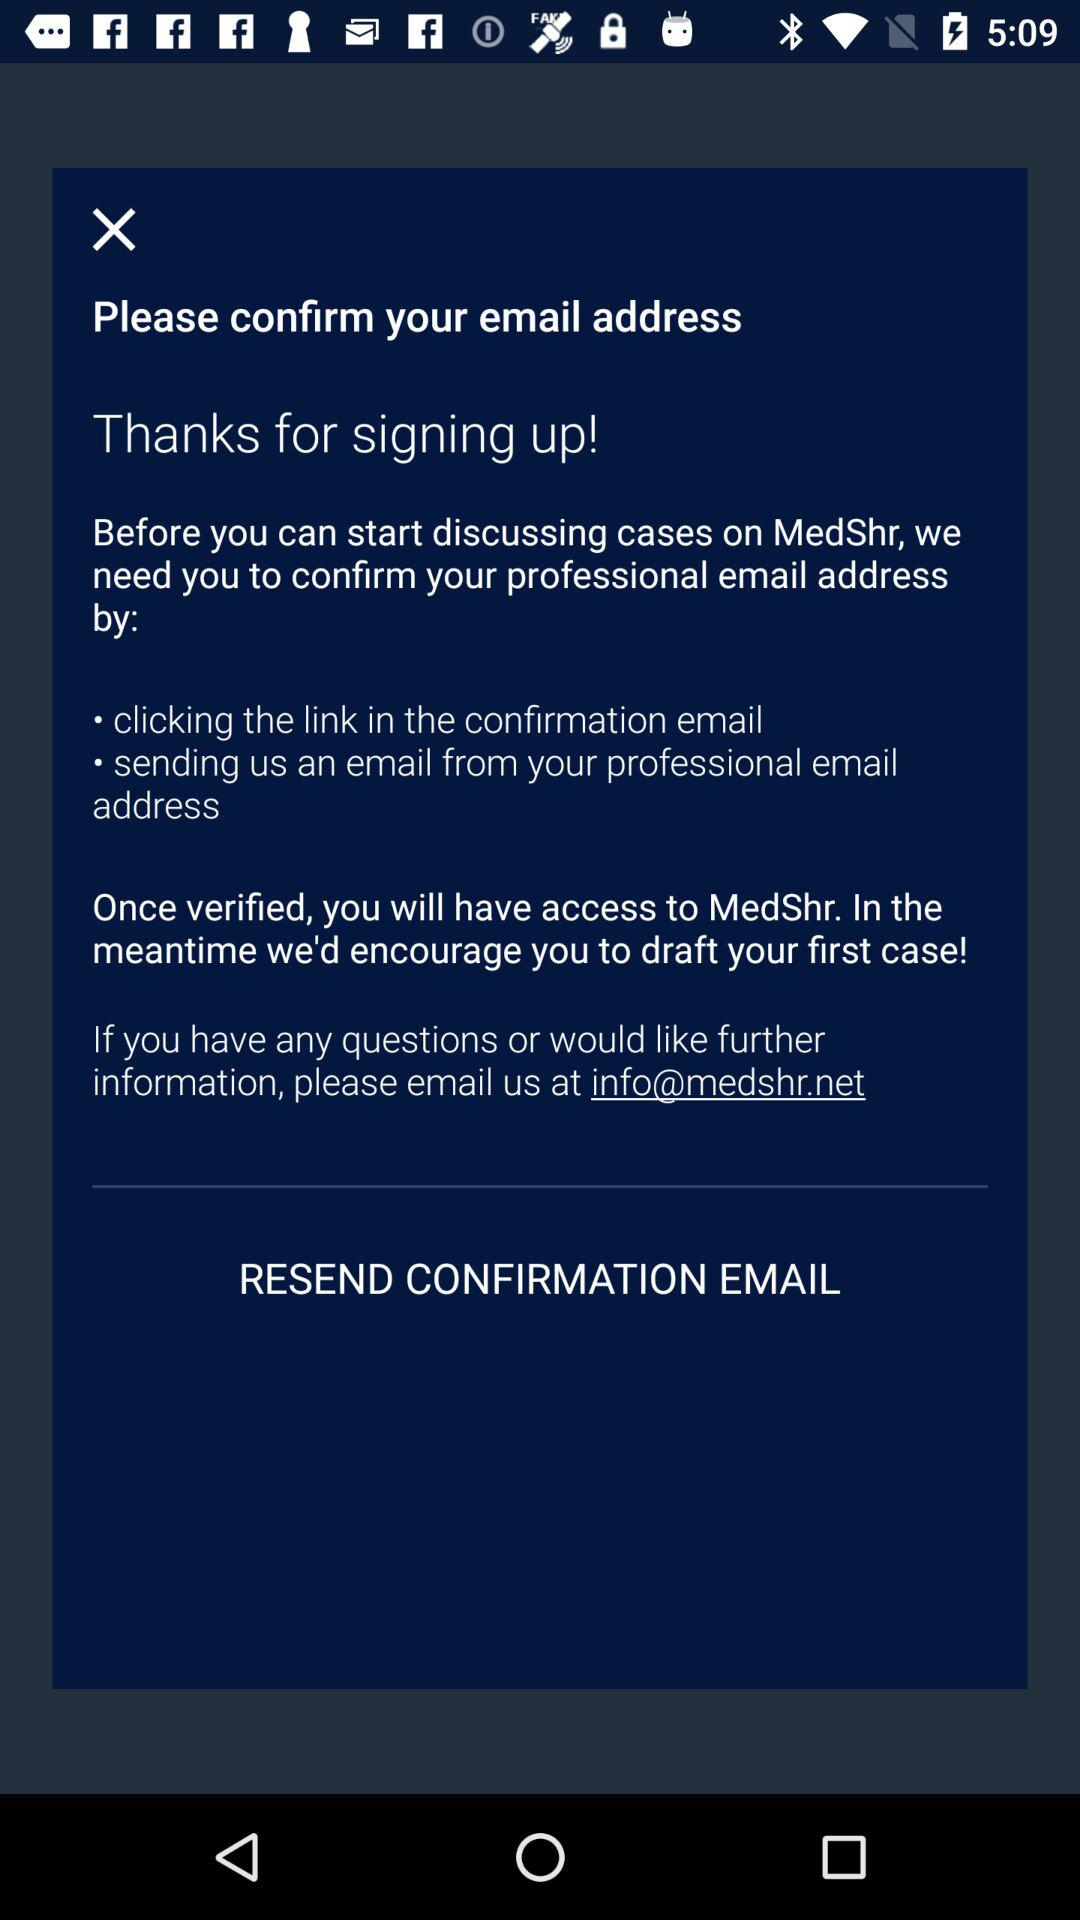How many ways are there to confirm your email address?
Answer the question using a single word or phrase. 2 